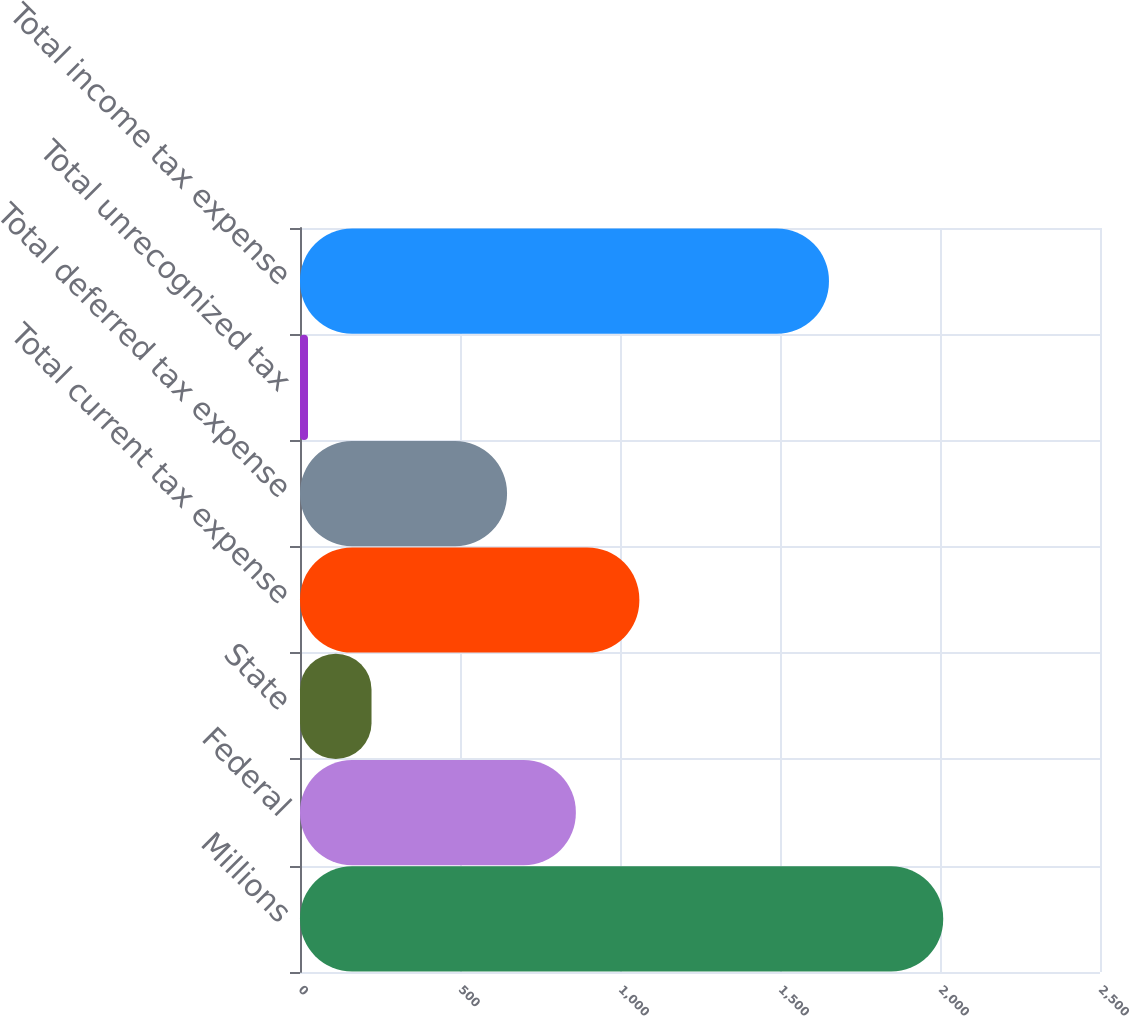<chart> <loc_0><loc_0><loc_500><loc_500><bar_chart><fcel>Millions<fcel>Federal<fcel>State<fcel>Total current tax expense<fcel>Total deferred tax expense<fcel>Total unrecognized tax<fcel>Total income tax expense<nl><fcel>2010<fcel>862<fcel>223.5<fcel>1060.5<fcel>647<fcel>25<fcel>1653<nl></chart> 